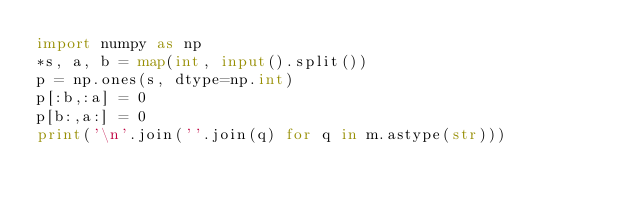Convert code to text. <code><loc_0><loc_0><loc_500><loc_500><_Python_>import numpy as np
*s, a, b = map(int, input().split())
p = np.ones(s, dtype=np.int)
p[:b,:a] = 0
p[b:,a:] = 0
print('\n'.join(''.join(q) for q in m.astype(str)))</code> 